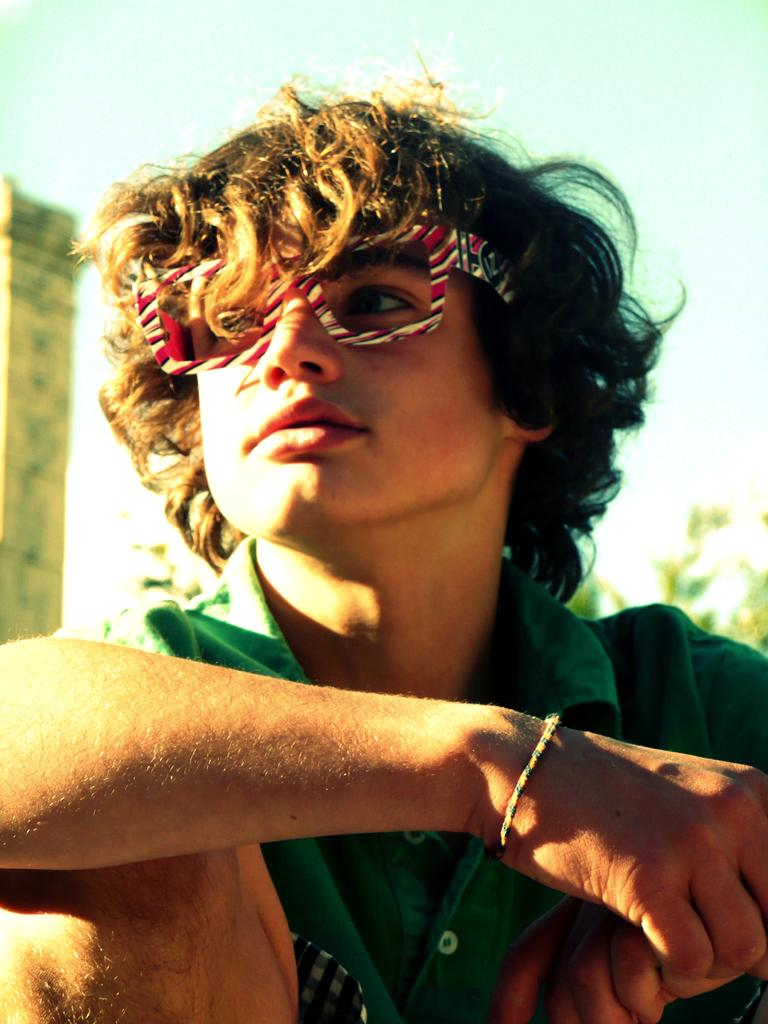Who or what is the main subject in the image? There is a person in the image. What can be seen on the right side of the image? There are leaves on the right side of the image. What is the object on the left side of the image? There is an object that looks like a wall on the left side of the image. How would you describe the background of the image? The background of the image is blurred. What type of breakfast is being served in the image? There is no breakfast visible in the image. What scent can be detected in the image? The image does not provide any information about scents. 